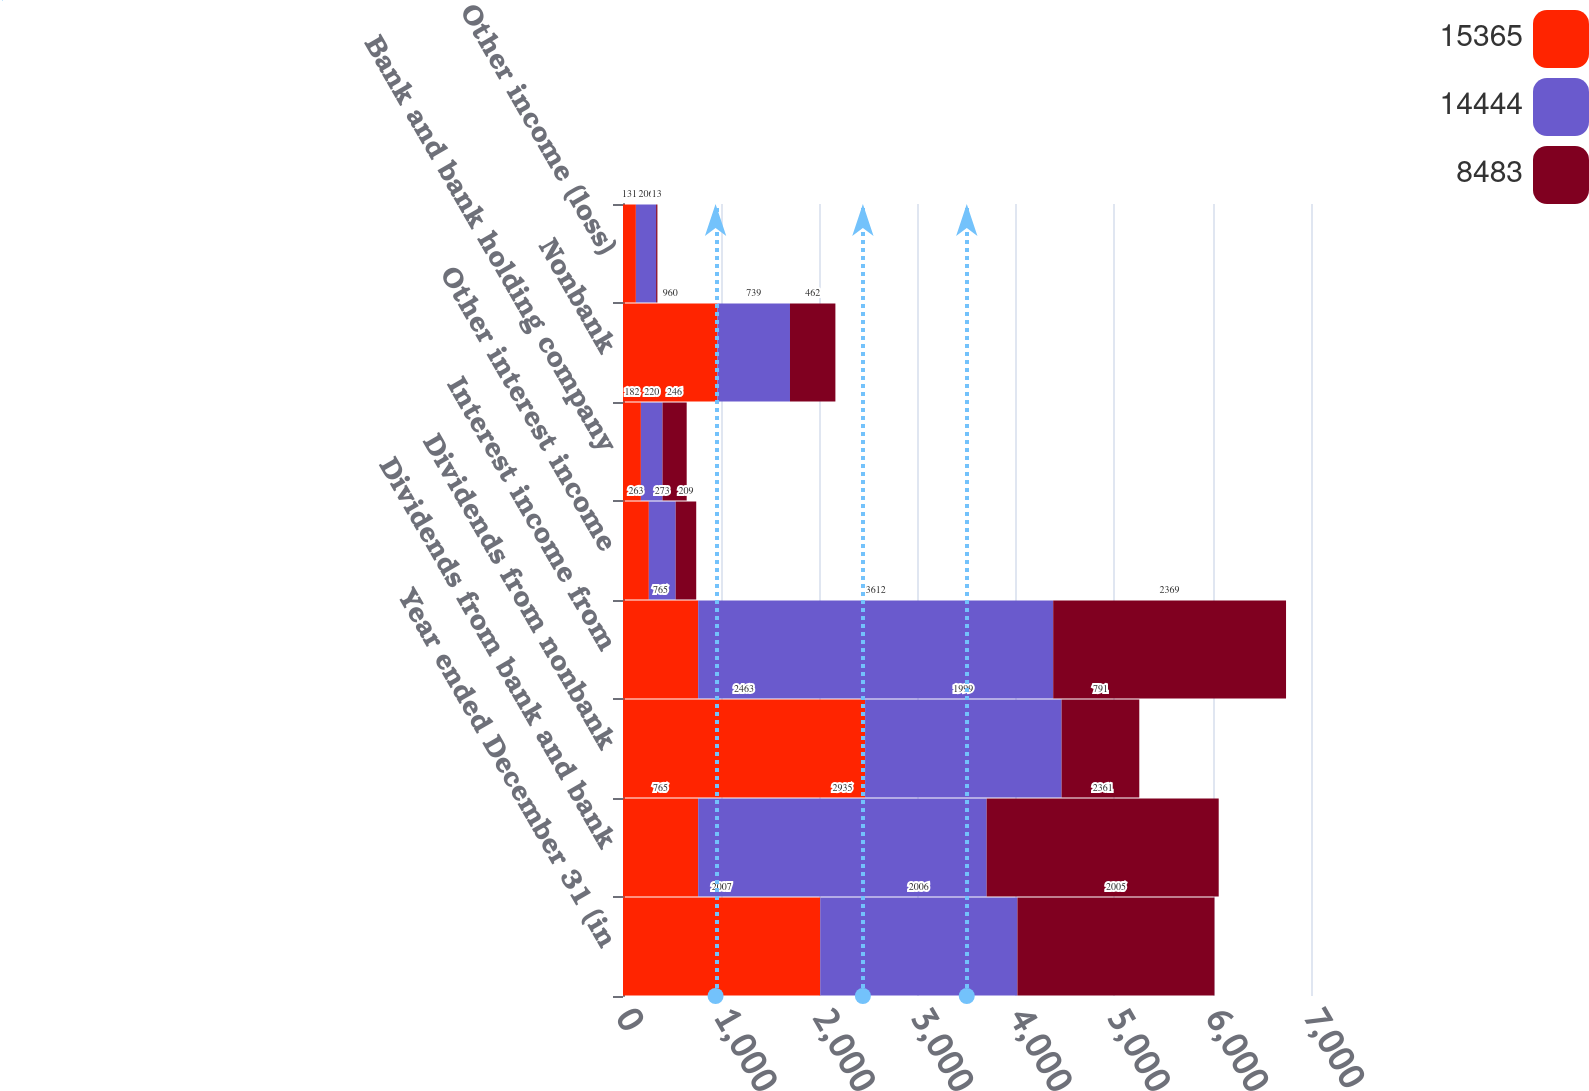Convert chart. <chart><loc_0><loc_0><loc_500><loc_500><stacked_bar_chart><ecel><fcel>Year ended December 31 (in<fcel>Dividends from bank and bank<fcel>Dividends from nonbank<fcel>Interest income from<fcel>Other interest income<fcel>Bank and bank holding company<fcel>Nonbank<fcel>Other income (loss)<nl><fcel>15365<fcel>2007<fcel>765<fcel>2463<fcel>765<fcel>263<fcel>182<fcel>960<fcel>131<nl><fcel>14444<fcel>2006<fcel>2935<fcel>1999<fcel>3612<fcel>273<fcel>220<fcel>739<fcel>206<nl><fcel>8483<fcel>2005<fcel>2361<fcel>791<fcel>2369<fcel>209<fcel>246<fcel>462<fcel>13<nl></chart> 